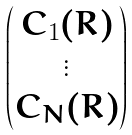<formula> <loc_0><loc_0><loc_500><loc_500>\begin{pmatrix} C _ { 1 } ( R ) \\ \vdots \\ C _ { N } ( R ) \end{pmatrix}</formula> 